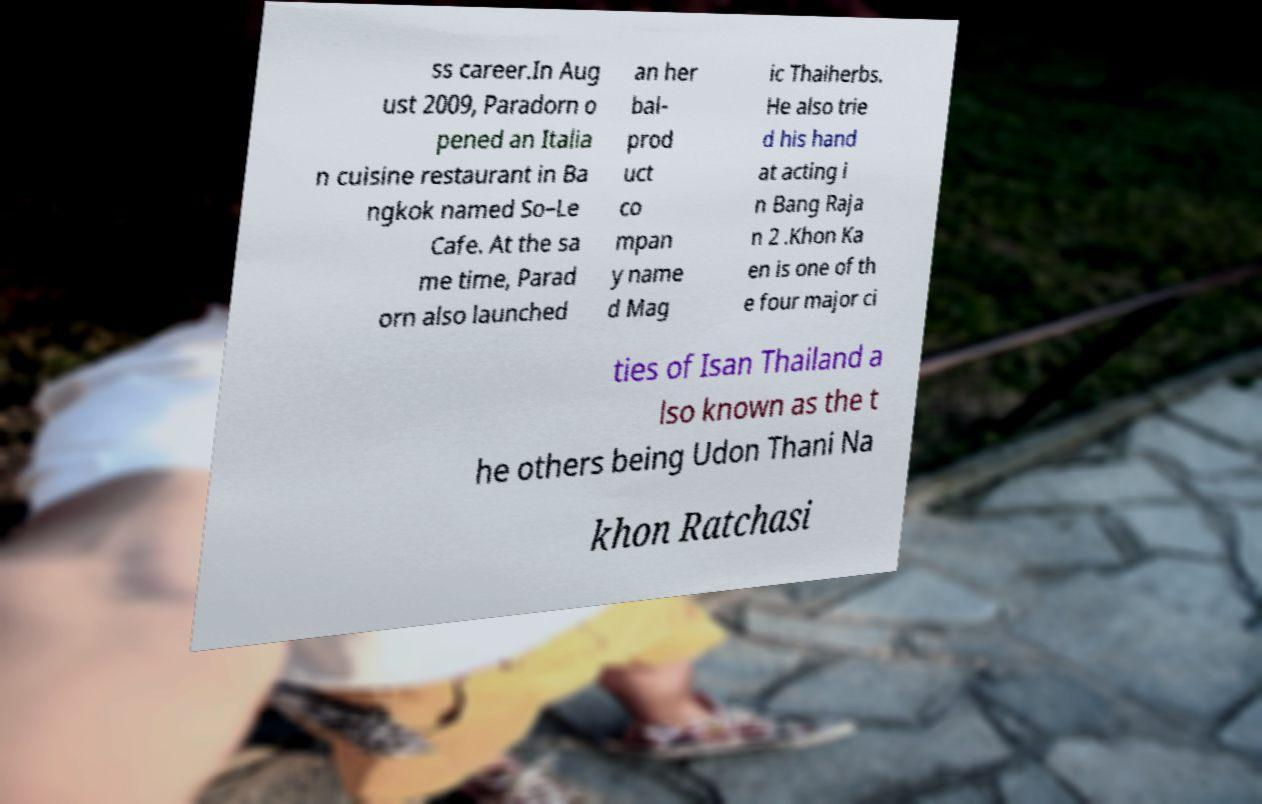I need the written content from this picture converted into text. Can you do that? ss career.In Aug ust 2009, Paradorn o pened an Italia n cuisine restaurant in Ba ngkok named So–Le Cafe. At the sa me time, Parad orn also launched an her bal- prod uct co mpan y name d Mag ic Thaiherbs. He also trie d his hand at acting i n Bang Raja n 2 .Khon Ka en is one of th e four major ci ties of Isan Thailand a lso known as the t he others being Udon Thani Na khon Ratchasi 